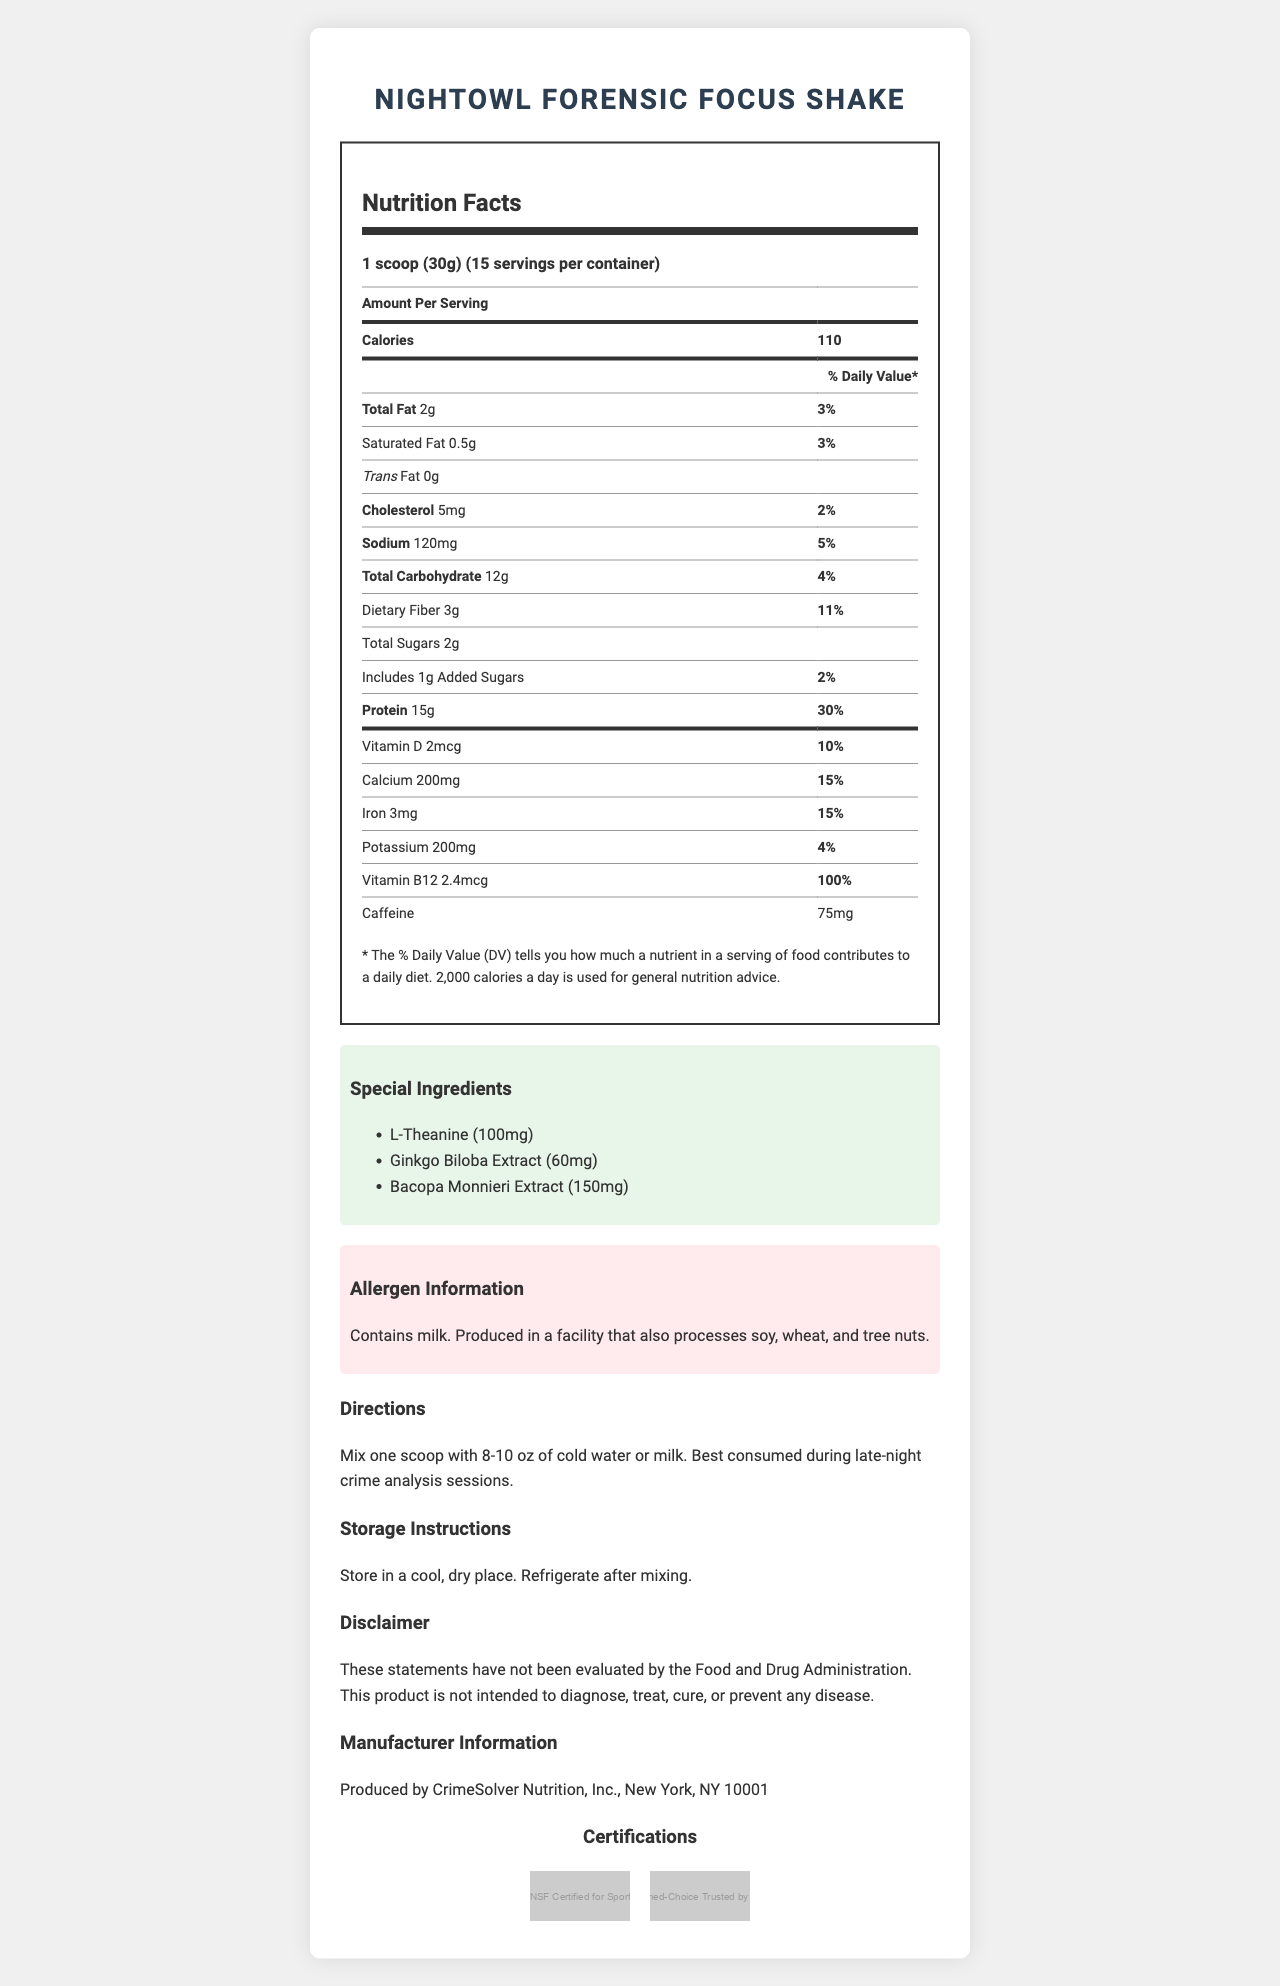how many servings are in a container? The document states under the **serving size** section that there are 15 servings per container.
Answer: 15 servings what is the amount of protein per serving? The document lists the protein content directly under its own section as 15g.
Answer: 15g describe the allergen information provided The allergen information section specifically mentions the presence of milk and the possibility of cross-contamination with soy, wheat, and tree nuts.
Answer: Contains milk. Produced in a facility that also processes soy, wheat, and tree nuts. is there any caffeine in the product? The "Nutrition Facts" table mentions caffeine content of 75mg per serving.
Answer: Yes what is the calorie count per serving? The "Nutrition Facts" table lists calories at the top with 110 per serving.
Answer: 110 calories what is the recommended consumption time for the NightOwl Forensic Focus Shake? A. Morning B. Afternoon C. Evening D. Late-night The "Directions" section advises that the shake is best consumed during late-night crime analysis sessions.
Answer: D which vitamin has the highest percent daily value in the product? I. Vitamin D II. Calcium III. Vitamin B12 IV. Iron Vitamin B12 has the highest percent daily value at 100%, as noted in the "Nutrition Facts" table.
Answer: III what is the serving size of the NightOwl Forensic Focus Shake? The "serving size" section specifies that one serving is 1 scoop (30g).
Answer: 1 scoop (30g) is the product NSF Certified for Sport? The "Certifications" section includes an image indicating that the product is "NSF Certified for Sport."
Answer: Yes what is the special role of L-Theanine in the product? The document lists L-Theanine as a special ingredient but does not provide details on its role.
Answer: Not enough information describe the main idea of the document The document covers various aspects of the product, emphasizing its tailored use for forensic professionals and providing comprehensive nutritional and usage information.
Answer: The document provides a detailed description of the NightOwl Forensic Focus Shake, including its nutrition facts, special ingredients, allergen information, directions for use, storage instructions, and certifications. It is tailored for forensic psychologists and crime analysts to help maintain focus during late-night work sessions. 